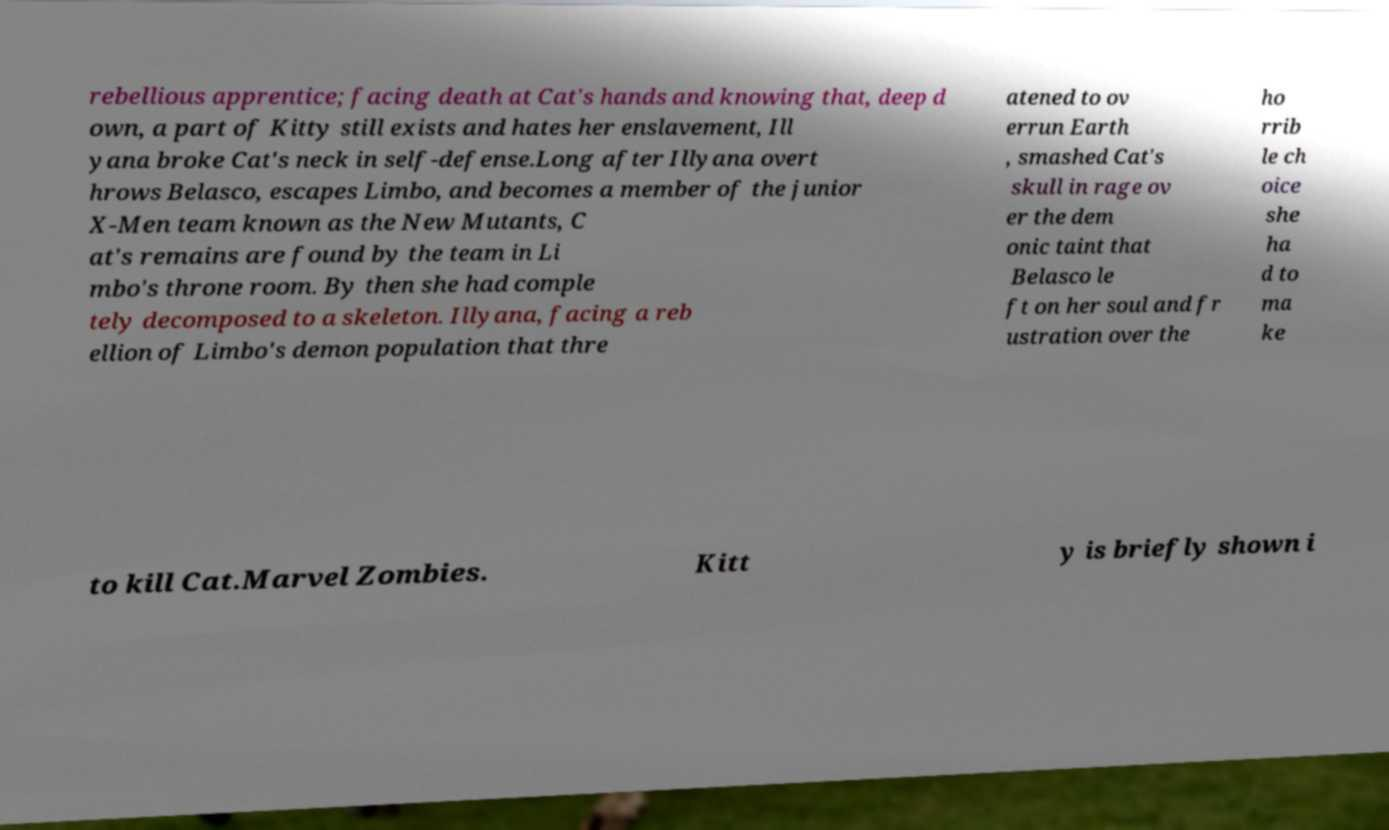Could you assist in decoding the text presented in this image and type it out clearly? rebellious apprentice; facing death at Cat's hands and knowing that, deep d own, a part of Kitty still exists and hates her enslavement, Ill yana broke Cat's neck in self-defense.Long after Illyana overt hrows Belasco, escapes Limbo, and becomes a member of the junior X-Men team known as the New Mutants, C at's remains are found by the team in Li mbo's throne room. By then she had comple tely decomposed to a skeleton. Illyana, facing a reb ellion of Limbo's demon population that thre atened to ov errun Earth , smashed Cat's skull in rage ov er the dem onic taint that Belasco le ft on her soul and fr ustration over the ho rrib le ch oice she ha d to ma ke to kill Cat.Marvel Zombies. Kitt y is briefly shown i 